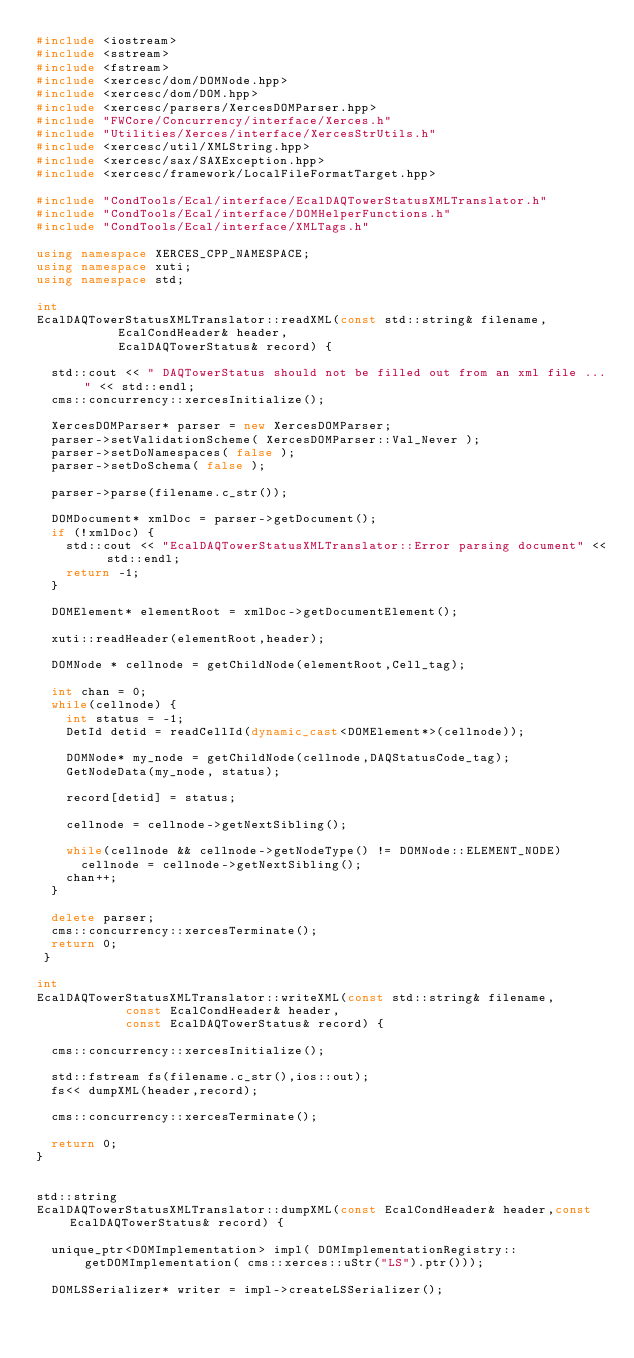<code> <loc_0><loc_0><loc_500><loc_500><_C++_>#include <iostream>
#include <sstream>
#include <fstream>
#include <xercesc/dom/DOMNode.hpp>
#include <xercesc/dom/DOM.hpp>
#include <xercesc/parsers/XercesDOMParser.hpp>
#include "FWCore/Concurrency/interface/Xerces.h"
#include "Utilities/Xerces/interface/XercesStrUtils.h"
#include <xercesc/util/XMLString.hpp>
#include <xercesc/sax/SAXException.hpp>
#include <xercesc/framework/LocalFileFormatTarget.hpp>

#include "CondTools/Ecal/interface/EcalDAQTowerStatusXMLTranslator.h"
#include "CondTools/Ecal/interface/DOMHelperFunctions.h"
#include "CondTools/Ecal/interface/XMLTags.h"

using namespace XERCES_CPP_NAMESPACE;
using namespace xuti;
using namespace std;

int
EcalDAQTowerStatusXMLTranslator::readXML(const std::string& filename, 
					 EcalCondHeader& header,
					 EcalDAQTowerStatus& record) {

  std::cout << " DAQTowerStatus should not be filled out from an xml file ..." << std::endl;
  cms::concurrency::xercesInitialize();

  XercesDOMParser* parser = new XercesDOMParser;
  parser->setValidationScheme( XercesDOMParser::Val_Never );
  parser->setDoNamespaces( false );
  parser->setDoSchema( false );
  
  parser->parse(filename.c_str());

  DOMDocument* xmlDoc = parser->getDocument();
  if (!xmlDoc) {
    std::cout << "EcalDAQTowerStatusXMLTranslator::Error parsing document" << std::endl;
    return -1;
  }

  DOMElement* elementRoot = xmlDoc->getDocumentElement();

  xuti::readHeader(elementRoot,header);

  DOMNode * cellnode = getChildNode(elementRoot,Cell_tag);

  int chan = 0;
  while(cellnode) {
    int status = -1;
    DetId detid = readCellId(dynamic_cast<DOMElement*>(cellnode));

    DOMNode* my_node = getChildNode(cellnode,DAQStatusCode_tag);
    GetNodeData(my_node, status);

    record[detid] = status;

    cellnode = cellnode->getNextSibling();

    while(cellnode && cellnode->getNodeType() != DOMNode::ELEMENT_NODE)
      cellnode = cellnode->getNextSibling();
    chan++;
  } 

  delete parser;
  cms::concurrency::xercesTerminate();
  return 0;
 }

int
EcalDAQTowerStatusXMLTranslator::writeXML(const std::string& filename, 
					  const EcalCondHeader& header,
					  const EcalDAQTowerStatus& record) {

  cms::concurrency::xercesInitialize();

  std::fstream fs(filename.c_str(),ios::out);
  fs<< dumpXML(header,record);

  cms::concurrency::xercesTerminate();

  return 0;  
}


std::string
EcalDAQTowerStatusXMLTranslator::dumpXML(const EcalCondHeader& header,const EcalDAQTowerStatus& record) {

  unique_ptr<DOMImplementation> impl( DOMImplementationRegistry::getDOMImplementation( cms::xerces::uStr("LS").ptr()));
  
  DOMLSSerializer* writer = impl->createLSSerializer();</code> 